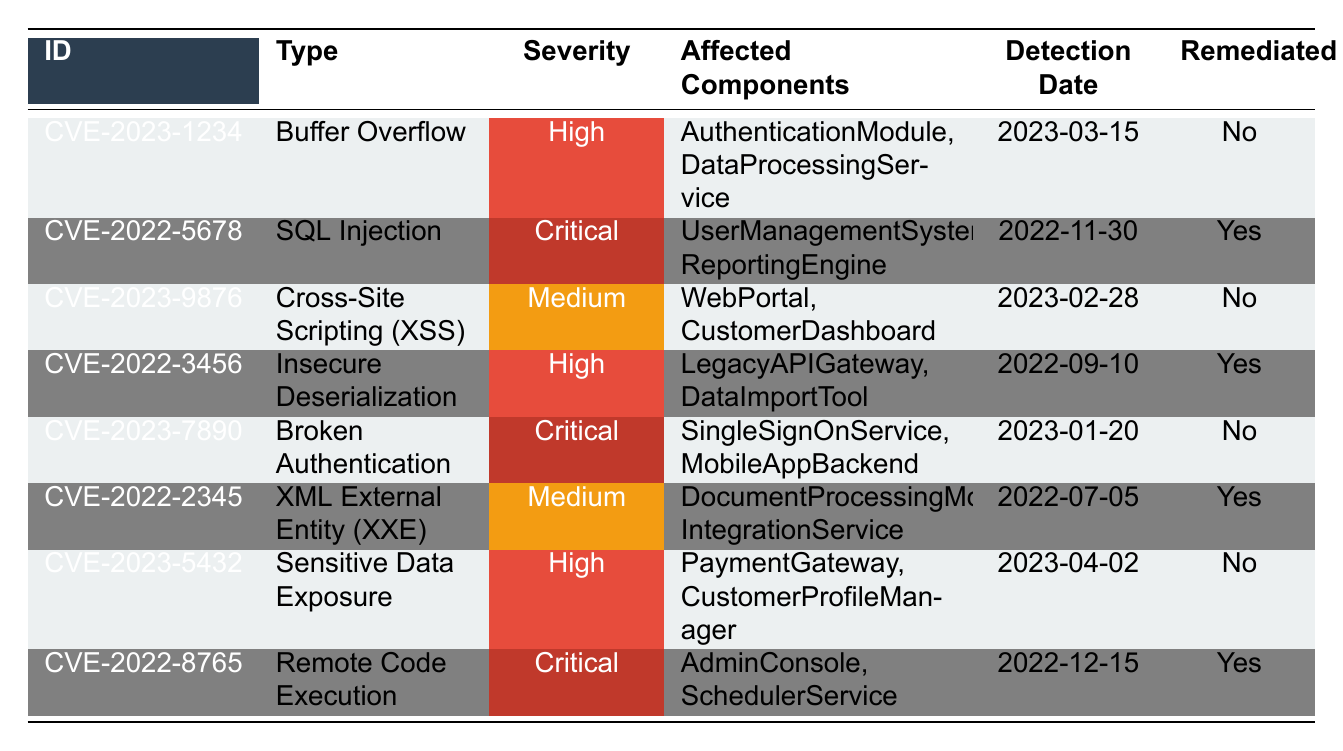What is the most recent vulnerability detected according to the table? The table lists vulnerabilities in order by their detection date. The most recent date mentioned is 2023-04-02 for CVE-2023-5432, which is "Sensitive Data Exposure."
Answer: CVE-2023-5432 How many vulnerabilities have been remediated? By counting the "Yes" responses in the "Remediated" column, there are 4 vulnerabilities that have been marked as remediated in the table.
Answer: 4 Which vulnerability type is most frequently found in the table? The types listed in the table are unique; thus, a frequency count shows that none of them repeat. Therefore, the most common types are all singular occurrences.
Answer: None Is there a vulnerability related to "Authentication"? The affected components for CVE-2023-1234 ("Buffer Overflow") and CVE-2023-7890 ("Broken Authentication") include terms related to authentication. Hence, there are vulnerabilities relevant to authentication.
Answer: Yes What is the severity of the vulnerability related to "SQL Injection"? Looking at the row for CVE-2022-5678, the severity indicated for this vulnerability is "Critical."
Answer: Critical Out of all vulnerabilities, which has the highest severity and is not remediated? The highest severity identified is "Critical," and checking the table, CVE-2023-7890 ("Broken Authentication") is marked as not remediated, making it the answer.
Answer: CVE-2023-7890 How many vulnerabilities were detected in 2022? By analyzing the detection dates of vulnerabilities listed, there are 4 vulnerabilities detected in 2022: CVE-2022-5678, CVE-2022-3456, CVE-2022-2345, and CVE-2022-8765.
Answer: 4 Which components are affected by the vulnerability with the highest severity? The table shows that both CVE-2022-5678 and CVE-2023-7890 have "Critical" severity. The affected components for CVE-2022-5678 are "UserManagementSystem, ReportingEngine," and for CVE-2023-7890 are "SingleSignOnService, MobileAppBackend." Thus, both sets of components are affected by critical vulnerabilities.
Answer: UserManagementSystem, ReportingEngine; SingleSignOnService, MobileAppBackend What is the ratio of remediated to non-remediated vulnerabilities? There are 4 remediated vulnerabilities and 4 non-remediated vulnerabilities, which gives a ratio of 4:4 or simplified to 1:1.
Answer: 1:1 What types of vulnerabilities are listed as having a medium severity? According to the table, the vulnerabilities classified as medium severity are "Cross-Site Scripting (XSS)" and "XML External Entity (XXE)."
Answer: Cross-Site Scripting (XSS), XML External Entity (XXE) 